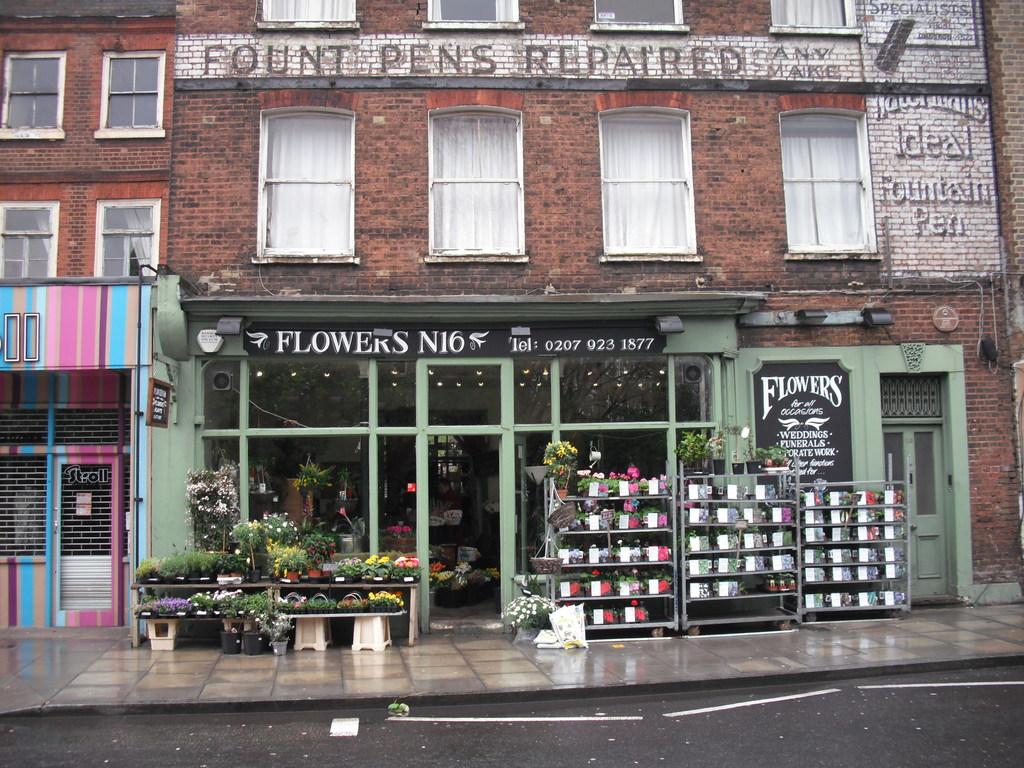What does that shop sell?
Keep it short and to the point. Flowers. What is written on the top of the building, black against white?
Your answer should be compact. Fount pens repaired. 